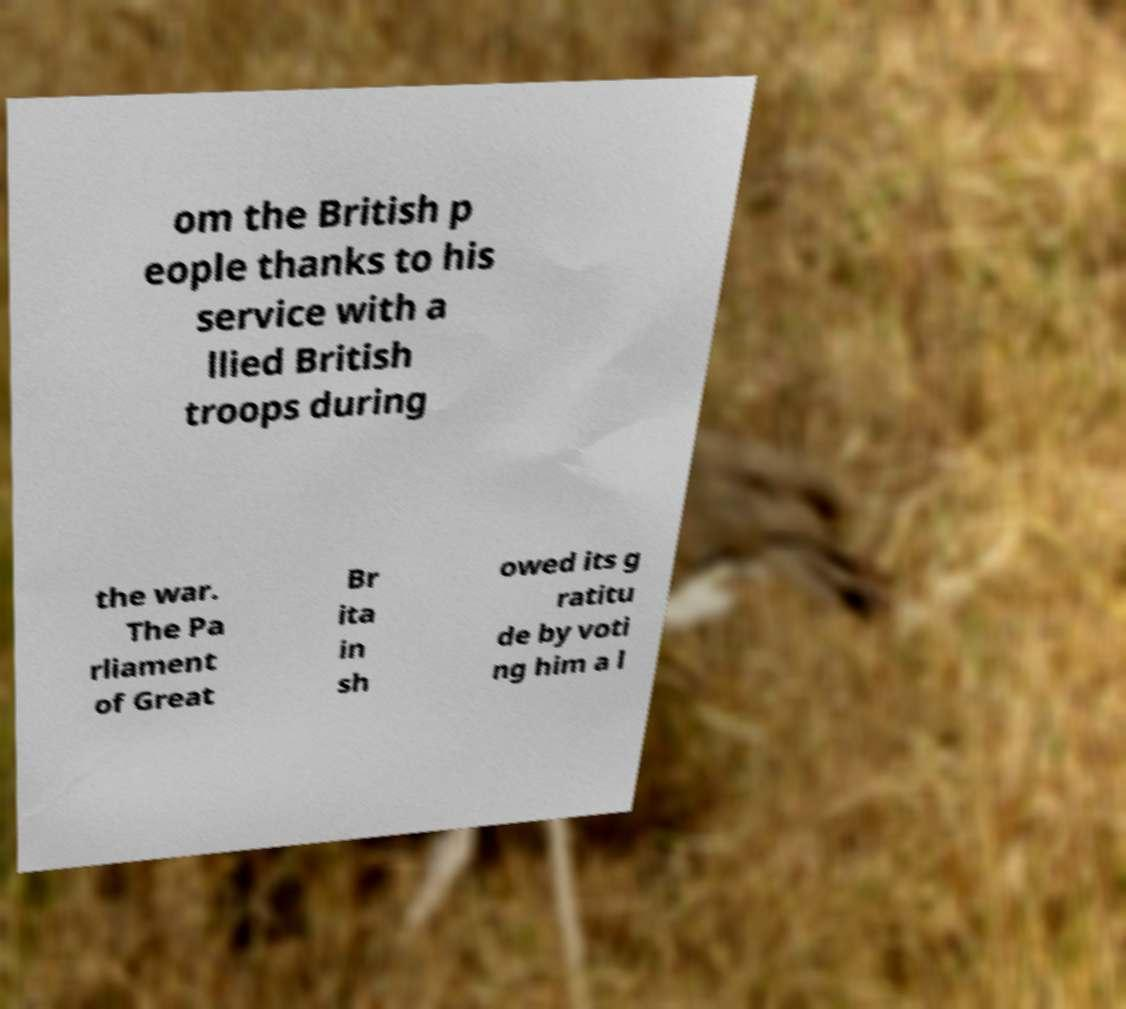There's text embedded in this image that I need extracted. Can you transcribe it verbatim? om the British p eople thanks to his service with a llied British troops during the war. The Pa rliament of Great Br ita in sh owed its g ratitu de by voti ng him a l 